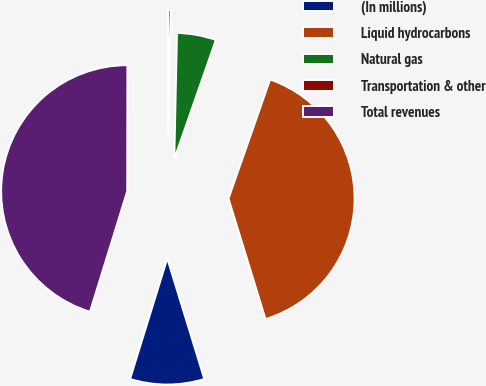Convert chart. <chart><loc_0><loc_0><loc_500><loc_500><pie_chart><fcel>(In millions)<fcel>Liquid hydrocarbons<fcel>Natural gas<fcel>Transportation & other<fcel>Total revenues<nl><fcel>9.51%<fcel>39.91%<fcel>5.01%<fcel>0.32%<fcel>45.25%<nl></chart> 